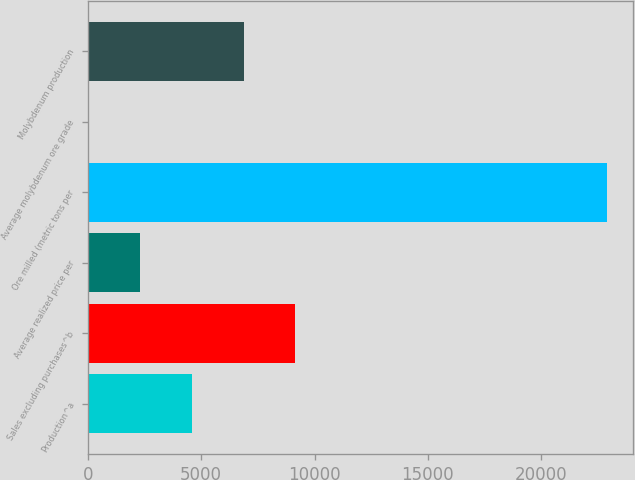<chart> <loc_0><loc_0><loc_500><loc_500><bar_chart><fcel>Production^a<fcel>Sales excluding purchases^b<fcel>Average realized price per<fcel>Ore milled (metric tons per<fcel>Average molybdenum ore grade<fcel>Molybdenum production<nl><fcel>4580.19<fcel>9160.14<fcel>2290.22<fcel>22900<fcel>0.25<fcel>6870.16<nl></chart> 